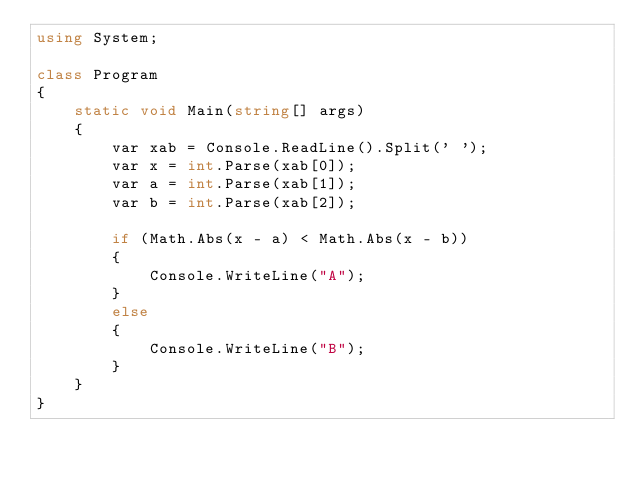<code> <loc_0><loc_0><loc_500><loc_500><_C#_>using System;

class Program
{
    static void Main(string[] args)
    {
        var xab = Console.ReadLine().Split(' ');
        var x = int.Parse(xab[0]);
        var a = int.Parse(xab[1]);
        var b = int.Parse(xab[2]);

        if (Math.Abs(x - a) < Math.Abs(x - b))
        {
            Console.WriteLine("A");
        }
        else
        {
            Console.WriteLine("B");
        }
    }
}</code> 